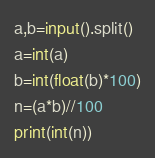<code> <loc_0><loc_0><loc_500><loc_500><_Python_>a,b=input().split()
a=int(a)
b=int(float(b)*100)
n=(a*b)//100
print(int(n))
</code> 